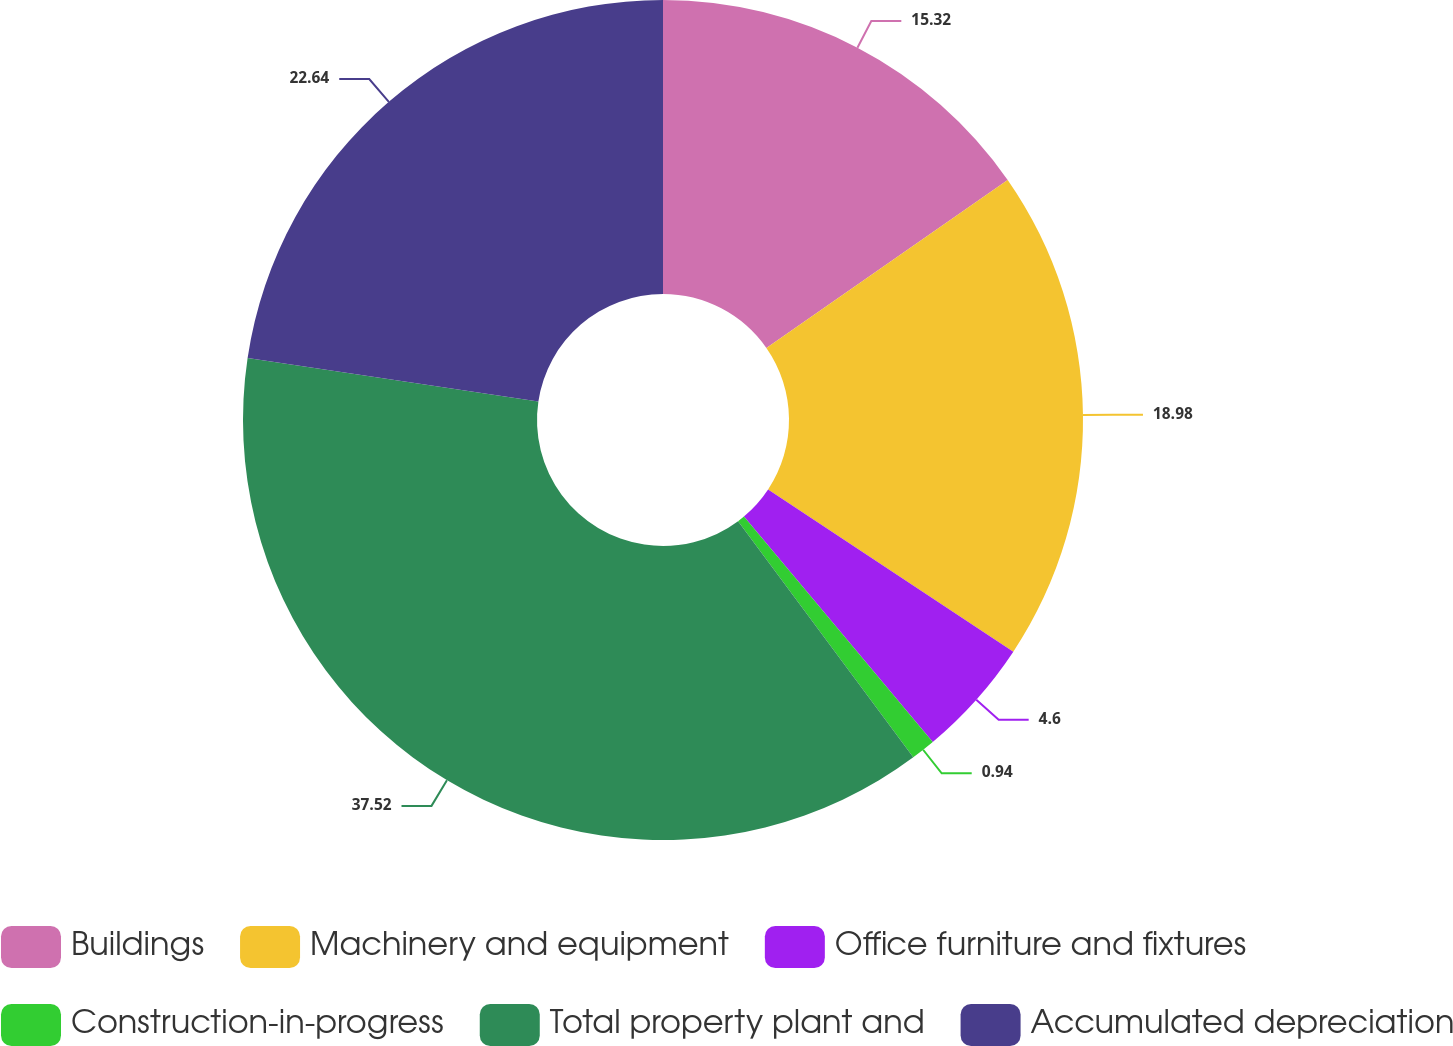<chart> <loc_0><loc_0><loc_500><loc_500><pie_chart><fcel>Buildings<fcel>Machinery and equipment<fcel>Office furniture and fixtures<fcel>Construction-in-progress<fcel>Total property plant and<fcel>Accumulated depreciation<nl><fcel>15.32%<fcel>18.98%<fcel>4.6%<fcel>0.94%<fcel>37.52%<fcel>22.64%<nl></chart> 